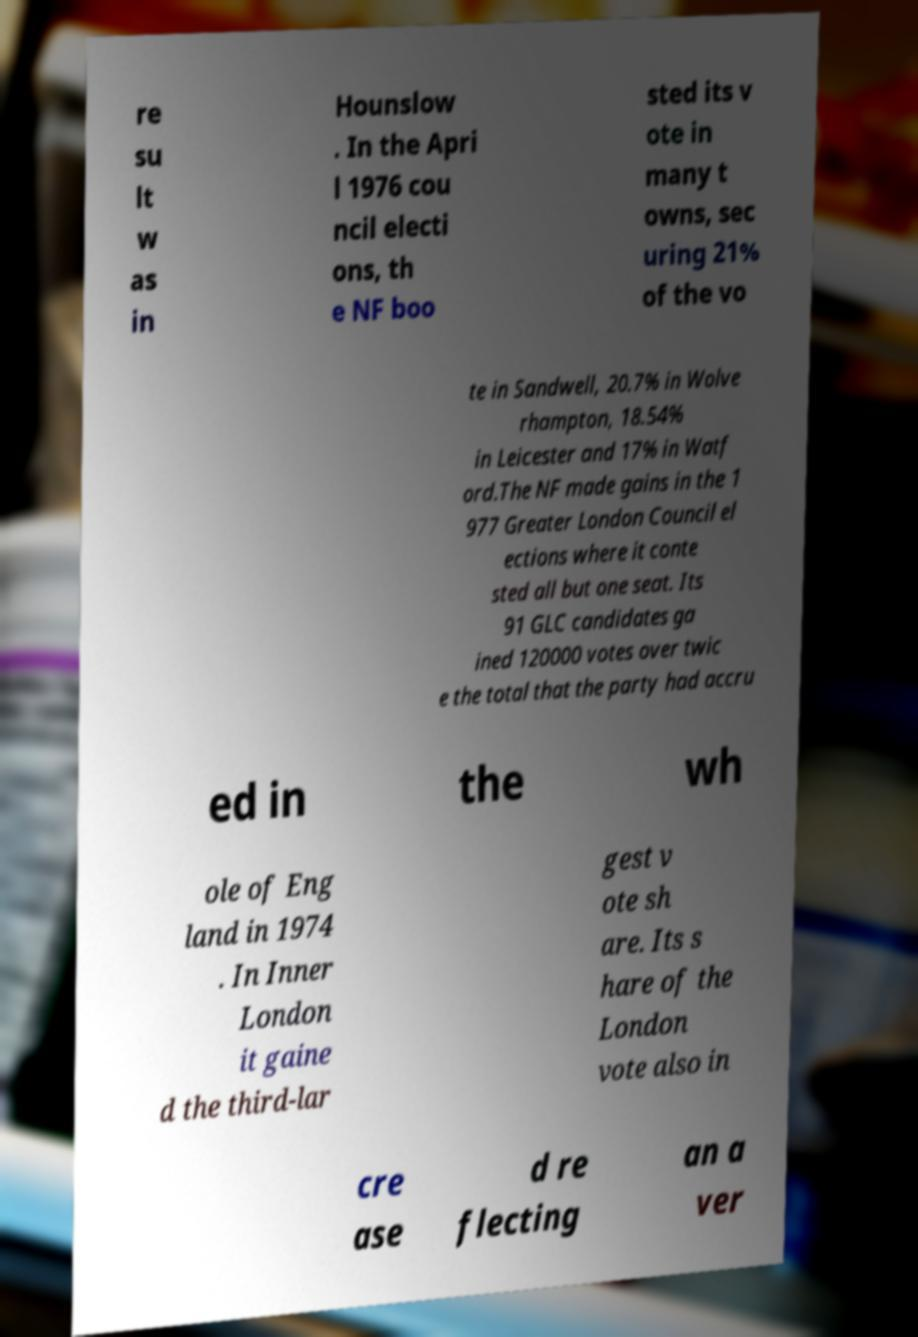Please identify and transcribe the text found in this image. re su lt w as in Hounslow . In the Apri l 1976 cou ncil electi ons, th e NF boo sted its v ote in many t owns, sec uring 21% of the vo te in Sandwell, 20.7% in Wolve rhampton, 18.54% in Leicester and 17% in Watf ord.The NF made gains in the 1 977 Greater London Council el ections where it conte sted all but one seat. Its 91 GLC candidates ga ined 120000 votes over twic e the total that the party had accru ed in the wh ole of Eng land in 1974 . In Inner London it gaine d the third-lar gest v ote sh are. Its s hare of the London vote also in cre ase d re flecting an a ver 